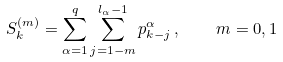<formula> <loc_0><loc_0><loc_500><loc_500>S _ { k } ^ { ( m ) } = \sum _ { \alpha = 1 } ^ { q } \sum _ { j = 1 - m } ^ { l _ { \alpha } - 1 } p _ { k - j } ^ { \alpha } \, , \quad m = 0 , 1</formula> 